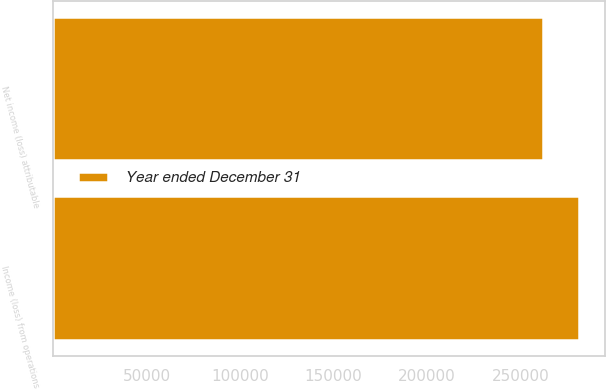<chart> <loc_0><loc_0><loc_500><loc_500><stacked_bar_chart><ecel><fcel>Income (loss) from operations<fcel>Net income (loss) attributable<nl><fcel>nan<fcel>1<fcel>1<nl><fcel>Year ended December 31<fcel>281393<fcel>262270<nl></chart> 